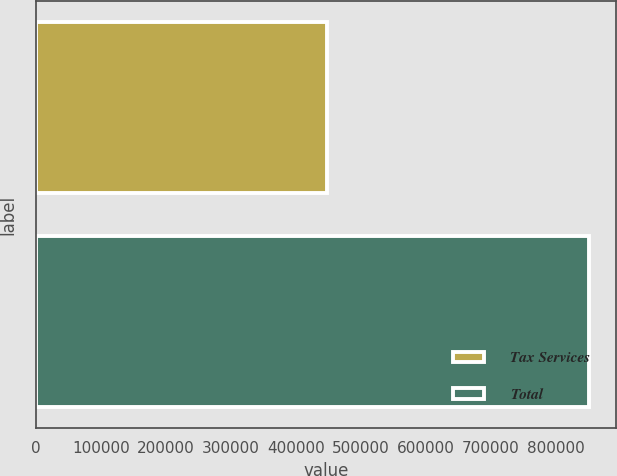Convert chart to OTSL. <chart><loc_0><loc_0><loc_500><loc_500><bar_chart><fcel>Tax Services<fcel>Total<nl><fcel>447591<fcel>850230<nl></chart> 